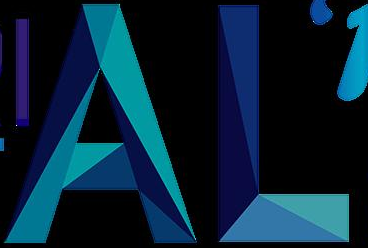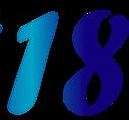Read the text content from these images in order, separated by a semicolon. AL; 18 